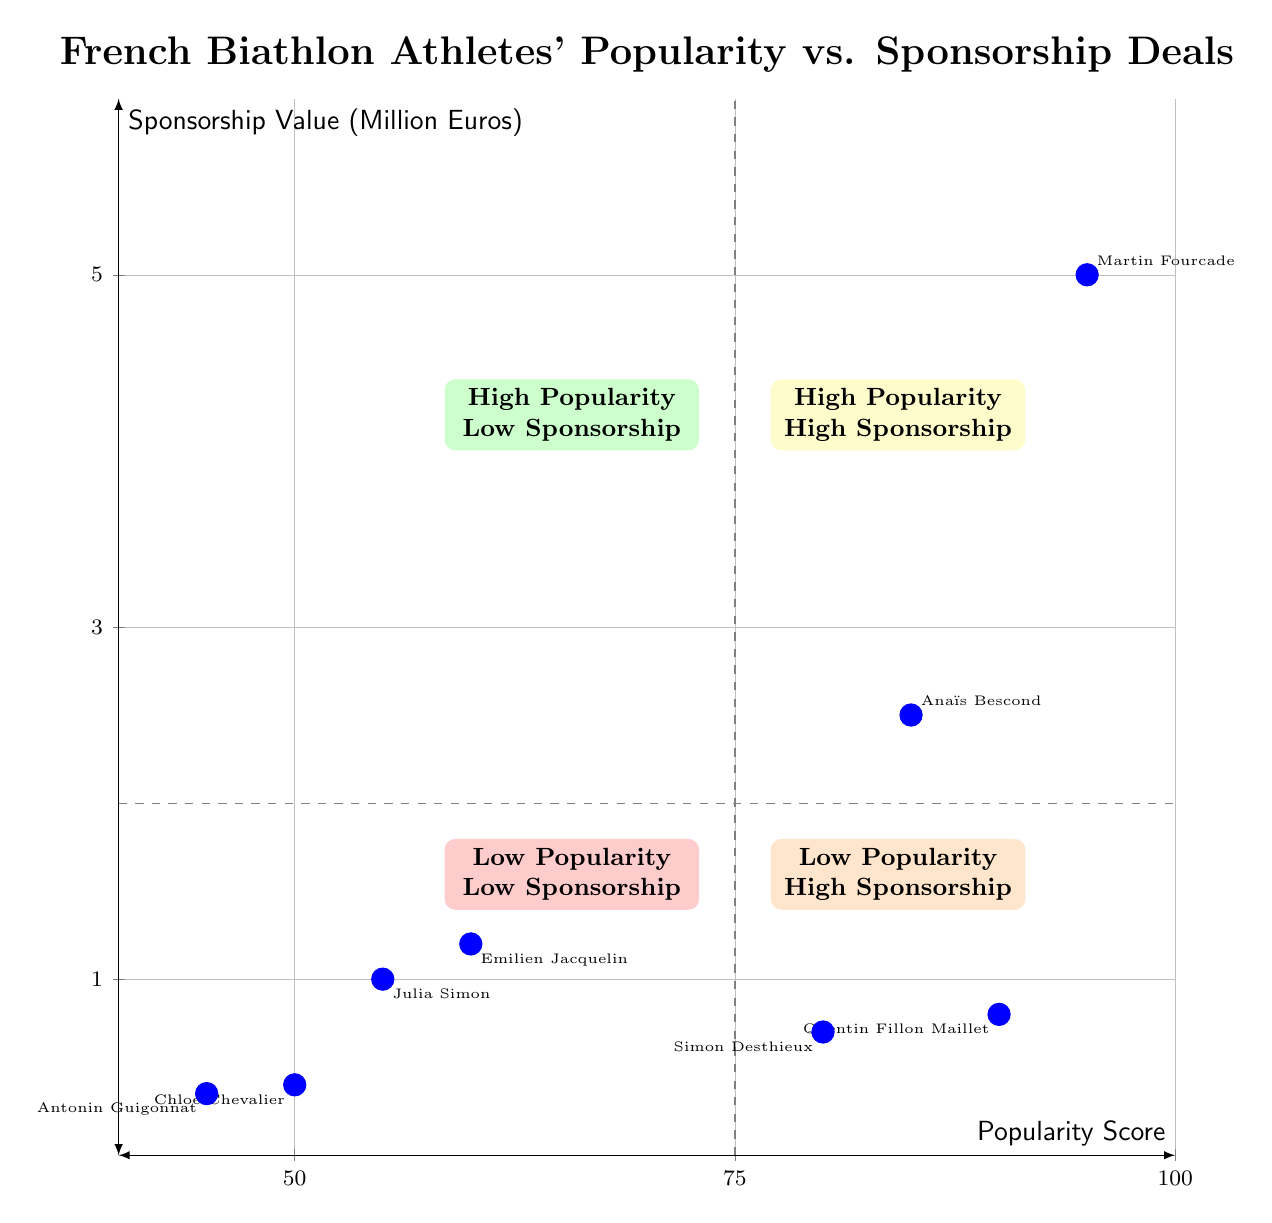What is the popularity score of Martin Fourcade? By locating Martin Fourcade on the diagram, we see he is in the high popularity-high sponsorship quadrant. His popularity score is indicated as 95.
Answer: 95 How many athletes are in the "High Popularity - Low Sponsorship" quadrant? In the quadrant labeled "High Popularity - Low Sponsorship," there are two athletes: Quentin Fillon Maillet and Simon Desthieux. Thus, the count is 2.
Answer: 2 Which athlete has the highest sponsorship deal value? Martin Fourcade has the highest sponsorship deal value of 3 million euros from Adidas, making him the athlete with the highest deal value in the diagram.
Answer: 3 million euros What is the sponsorship value of Julia Simon? Julia Simon is located in the "Low Popularity - High Sponsorship" quadrant. Her sponsorship deal value is stated as 1 million euros.
Answer: 1 million euros Which quadrant contains Emilien Jacquelin? Emilien Jacquelin is situated in the "Low Popularity - High Sponsorship" quadrant, demonstrated by his popularity score of 60 and a sponsorship deal value of 1.2 million euros.
Answer: Low Popularity - High Sponsorship What is the combined sponsorship value of Martin Fourcade's sponsors? Analyzing Martin Fourcade’s sponsorship deals, we find deal values of 3 million euros from Adidas and 2 million euros from Fischer, leading to a total combined value of 5 million euros.
Answer: 5 million euros How does the popularity score of Chloé Chevalier relate to the average score in her quadrant? Chloé Chevalier is in the "Low Popularity - Low Sponsorship" quadrant with a popularity score of 50. The average score of this quadrant is lower than her score, as the highest score is 60 and the lowest is 45.
Answer: Above average Which athlete shows a sponsorship value less than 1 million euros? In the diagram, both Chloé Chevalier and Antonin Guigonnat exhibit sponsorship values below 1 million euros, with their respective values being 0.4 million euros and 0.35 million euros.
Answer: Chloé Chevalier, Antonin Guigonnat What is the sponsorship deal value for Simon Desthieux? Simon Desthieux is represented in the high popularity-low sponsorship quadrant and has his sponsorship deal valued at 0.7 million euros.
Answer: 0.7 million euros 